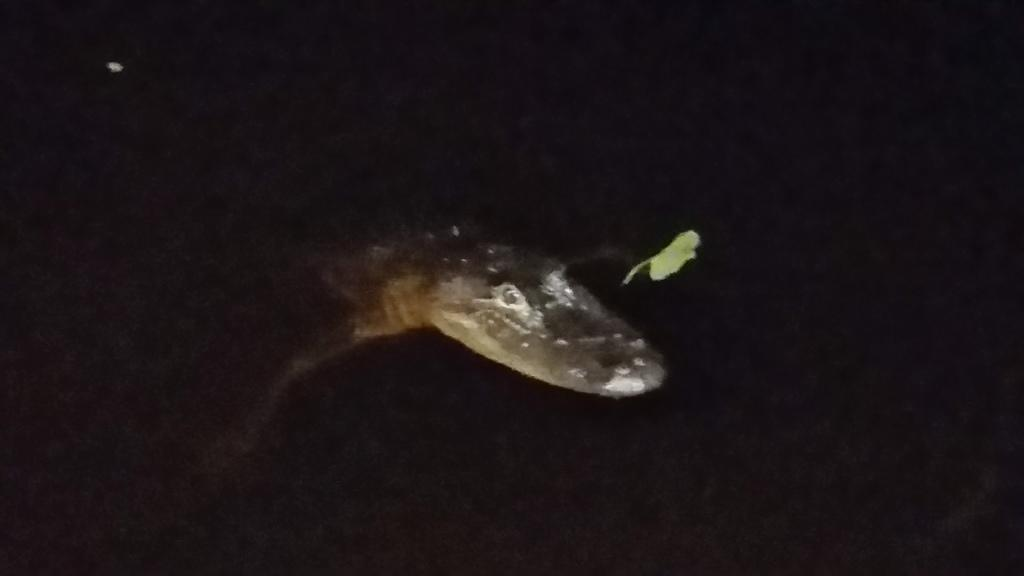What animal is present in the image? There is a snake in the image. What can be observed about the background of the image? The background of the image is dark. Can you determine the time of day based on the image? The image appears to be taken during nighttime. What is the weight of the class being taught by the snake in the image? There is no class being taught by the snake in the image, and therefore no weight can be determined. 